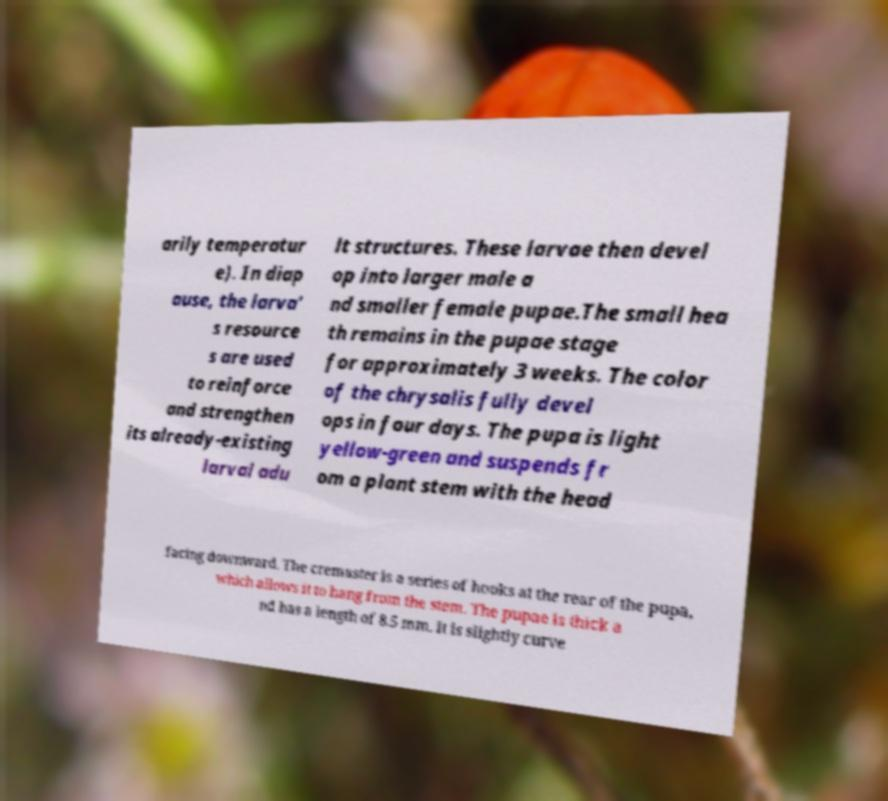Could you assist in decoding the text presented in this image and type it out clearly? arily temperatur e). In diap ause, the larva' s resource s are used to reinforce and strengthen its already-existing larval adu lt structures. These larvae then devel op into larger male a nd smaller female pupae.The small hea th remains in the pupae stage for approximately 3 weeks. The color of the chrysalis fully devel ops in four days. The pupa is light yellow-green and suspends fr om a plant stem with the head facing downward. The cremaster is a series of hooks at the rear of the pupa, which allows it to hang from the stem. The pupae is thick a nd has a length of 8.5 mm. It is slightly curve 